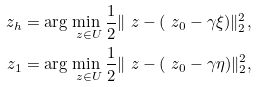Convert formula to latex. <formula><loc_0><loc_0><loc_500><loc_500>\ z _ { h } & = \arg \min _ { \ z \in U } \frac { 1 } { 2 } \| \ z - ( \ z _ { 0 } - \gamma \xi ) \| ^ { 2 } _ { 2 } , \\ \ z _ { 1 } & = \arg \min _ { \ z \in U } \frac { 1 } { 2 } \| \ z - ( \ z _ { 0 } - \gamma \eta ) \| ^ { 2 } _ { 2 } ,</formula> 